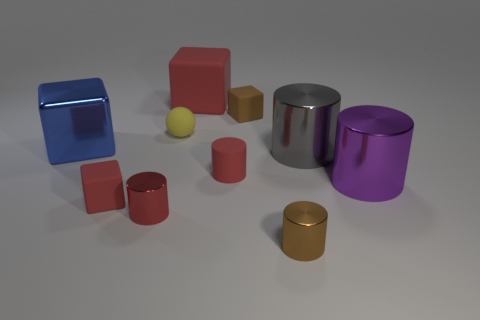Does the tiny shiny object left of the large rubber object have the same shape as the small brown thing in front of the tiny rubber cylinder?
Provide a succinct answer. Yes. What is the size of the gray metal object that is right of the red cube that is behind the rubber cube that is in front of the gray metallic thing?
Your answer should be compact. Large. What is the size of the brown object that is in front of the metal cube?
Your answer should be compact. Small. There is a small brown thing that is on the left side of the small brown cylinder; what is it made of?
Provide a succinct answer. Rubber. How many cyan things are tiny rubber balls or metallic blocks?
Your response must be concise. 0. Is the material of the blue thing the same as the red cube in front of the small yellow object?
Your answer should be very brief. No. Are there an equal number of large red matte things in front of the big purple metallic cylinder and small yellow rubber balls left of the brown cylinder?
Keep it short and to the point. No. There is a purple cylinder; is it the same size as the red object behind the small yellow matte object?
Offer a terse response. Yes. Is the number of red cubes behind the brown metal thing greater than the number of big cyan rubber spheres?
Give a very brief answer. Yes. What number of metallic objects have the same size as the brown rubber cube?
Provide a short and direct response. 2. 